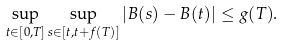Convert formula to latex. <formula><loc_0><loc_0><loc_500><loc_500>\sup _ { t \in [ 0 , T ] } { \sup _ { s \in [ t , t + f ( T ) ] } } \left | B ( s ) - B ( t ) \right | \leq g ( T ) .</formula> 